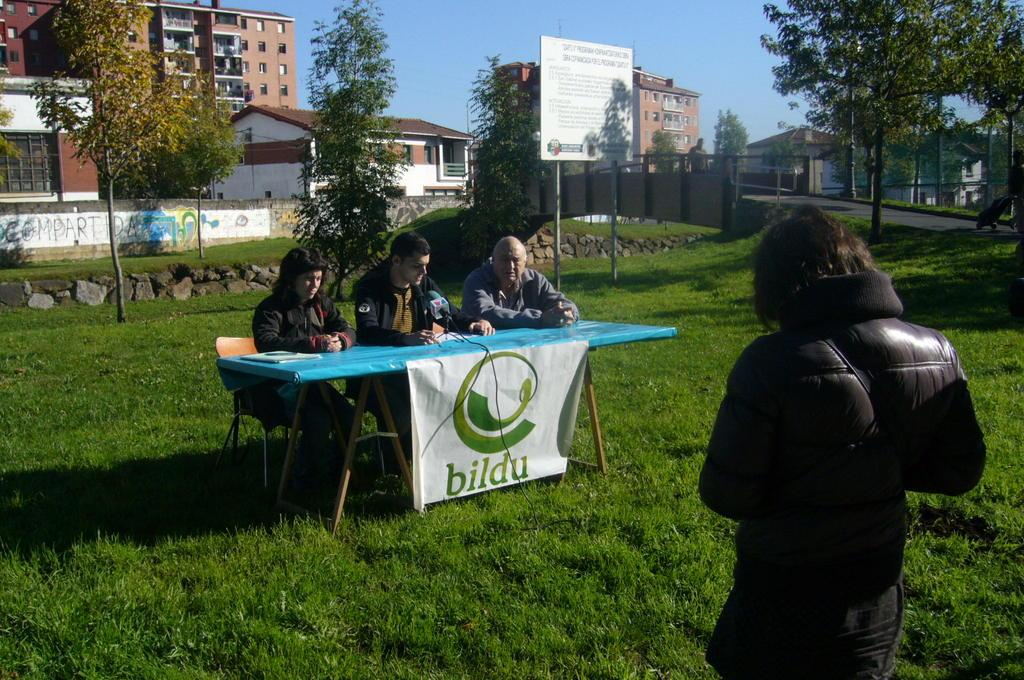<image>
Write a terse but informative summary of the picture. Three men are sitting at a table with a bildu banner. 